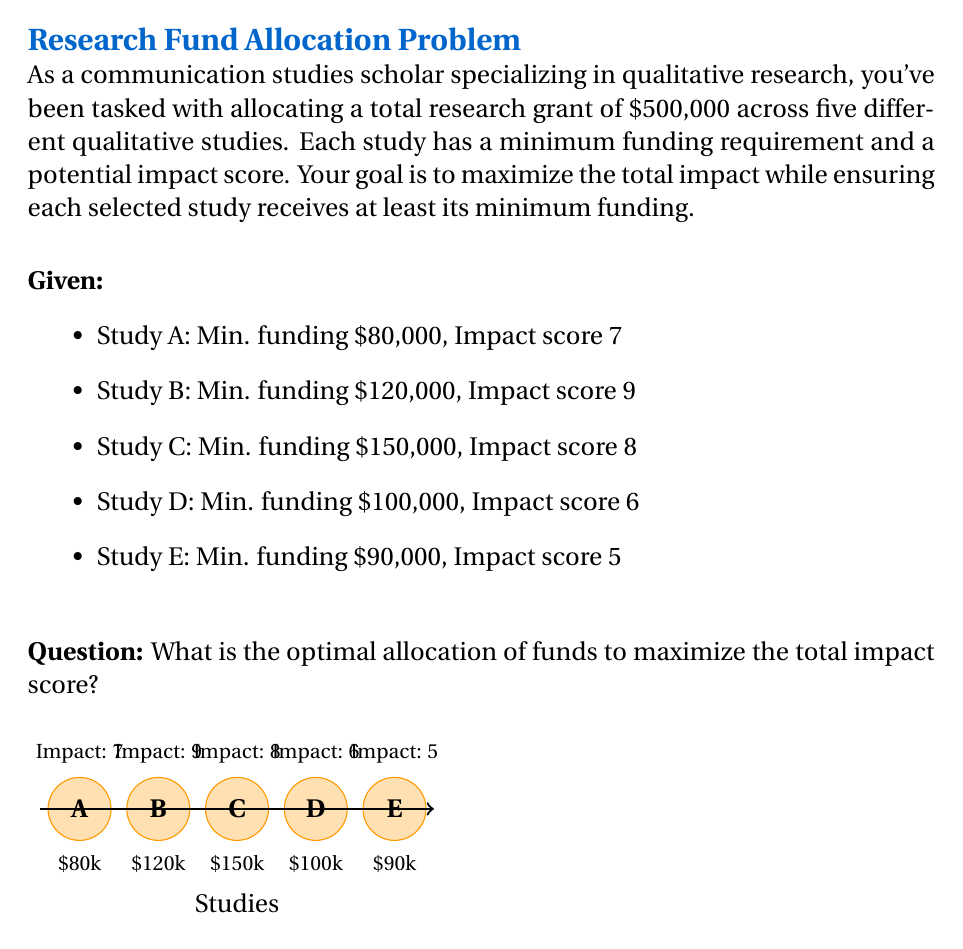Can you solve this math problem? To solve this optimization problem, we'll use the technique of integer linear programming. Let's follow these steps:

1) Define decision variables:
   Let $x_i$ be a binary variable for each study $i$, where:
   $x_i = 1$ if study $i$ is funded, and $x_i = 0$ if not.

2) Formulate the objective function:
   Maximize $Z = 7x_A + 9x_B + 8x_C + 6x_D + 5x_E$

3) Set up constraints:
   a) Budget constraint:
      $80000x_A + 120000x_B + 150000x_C + 100000x_D + 90000x_E \leq 500000$
   
   b) Binary constraints:
      $x_A, x_B, x_C, x_D, x_E \in \{0, 1\}$

4) Solve the integer linear programming problem:
   We can solve this using various methods, including branch and bound or cutting plane algorithms. However, given the small scale of this problem, we can also use exhaustive enumeration.

5) Evaluate all possible combinations:
   There are $2^5 = 32$ possible combinations of studies to fund. We'll check each valid combination (those that meet the budget constraint) and calculate its total impact score.

6) Find the optimal solution:
   After evaluation, we find that the optimal solution is to fund studies A, B, and C.

   This allocation uses:
   $80000 + 120000 + 150000 = 350000$, which is within the budget.

   The total impact score is:
   $7 + 9 + 8 = 24$, which is the maximum achievable within the constraints.

Therefore, the optimal allocation is to fully fund studies A, B, and C, leaving studies D and E unfunded.
Answer: Fund studies A ($80,000), B ($120,000), and C ($150,000) for a total impact score of 24. 